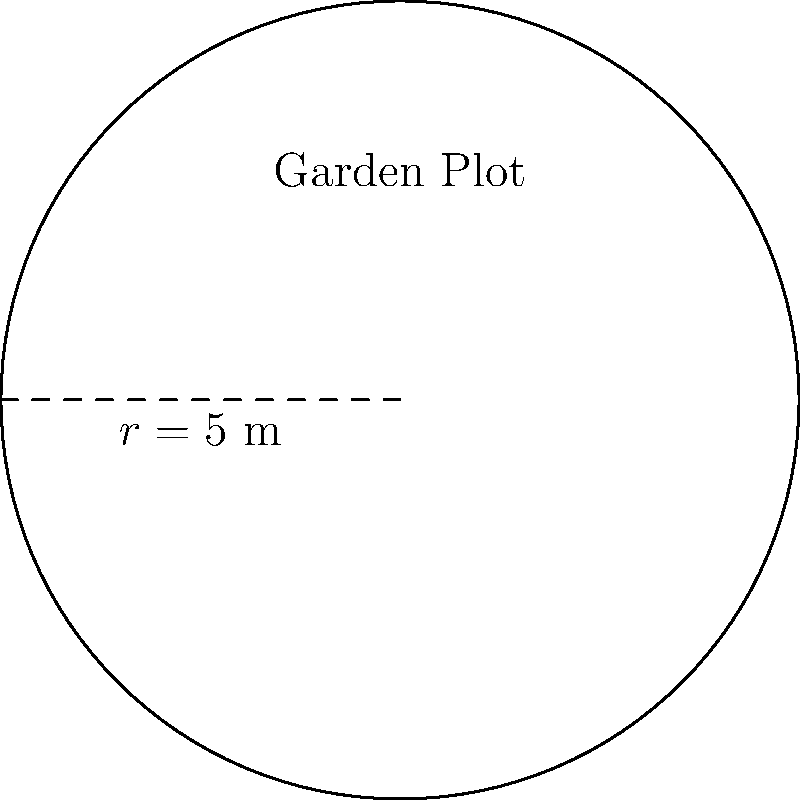As a mortgage broker, you're helping a client who wants to landscape their new property. They're planning a circular garden plot with a radius of 5 meters. What's the area of this garden plot? (Use $\pi = 3.14$ for your calculations) Let's approach this step-by-step:

1) The formula for the area of a circle is:
   $$A = \pi r^2$$
   where $A$ is the area and $r$ is the radius.

2) We're given that the radius is 5 meters and we should use $\pi = 3.14$.

3) Let's substitute these values into our formula:
   $$A = 3.14 \times 5^2$$

4) First, calculate $5^2$:
   $$A = 3.14 \times 25$$

5) Now, multiply:
   $$A = 78.5$$

6) The units will be square meters (m²) because we're calculating area.

Therefore, the area of the circular garden plot is 78.5 m².
Answer: 78.5 m² 